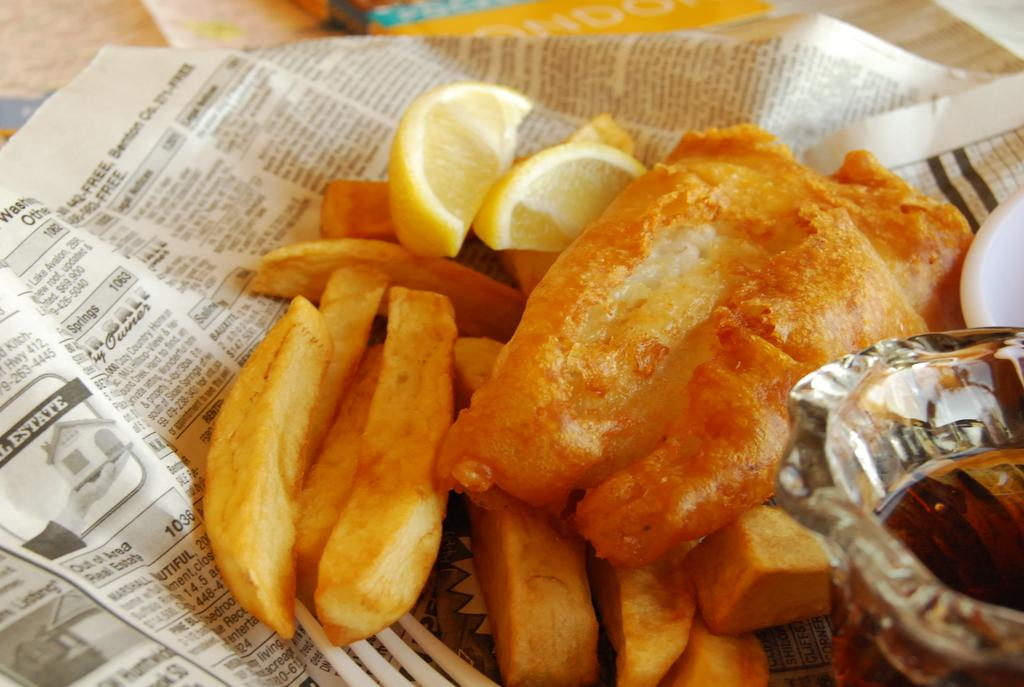What is the main object in the image? There is a newspaper in the image. What is placed on top of the newspaper? There are slices of lemon and french fries on the newspaper. Can you describe the color and transparency of any objects in the image? There are objects in the image that are white and transparent in color. What type of slave is depicted in the image? There is no depiction of a slave in the image; it features a newspaper with slices of lemon and french fries on it. What time of day is the image set in? The time of day is not specified in the image; it only shows a newspaper with slices of lemon and french fries on it. 